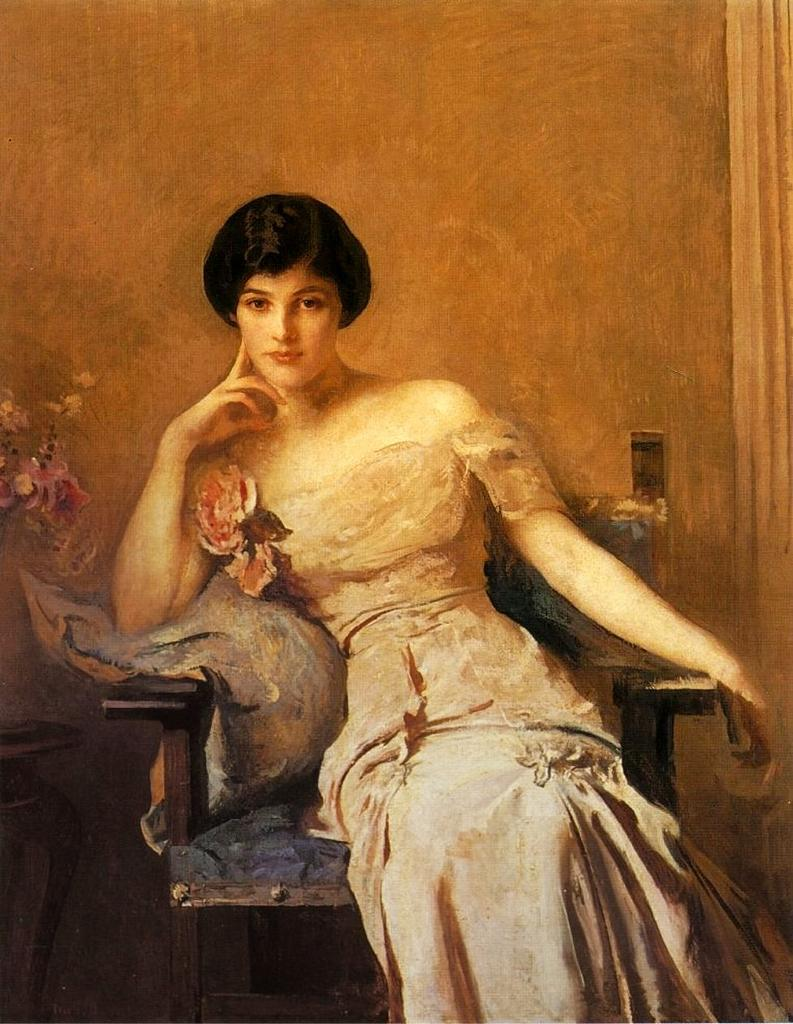What type of artwork is depicted in the image? The image appears to be a painting. Can you describe the woman in the image? There is a woman sitting in a chair in the image. What might be the subject of the painting? There is a possible flower depicted in the image. Where is the table located in the image? There is a table on the left side of the image. How many girls are holding a parcel in the image? There are no girls or parcels present in the image. 